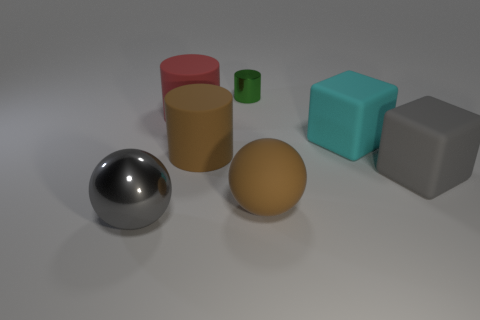Add 3 big blocks. How many objects exist? 10 Subtract all cylinders. How many objects are left? 4 Add 2 cyan objects. How many cyan objects are left? 3 Add 6 large shiny balls. How many large shiny balls exist? 7 Subtract 0 gray cylinders. How many objects are left? 7 Subtract all large red matte cylinders. Subtract all purple cubes. How many objects are left? 6 